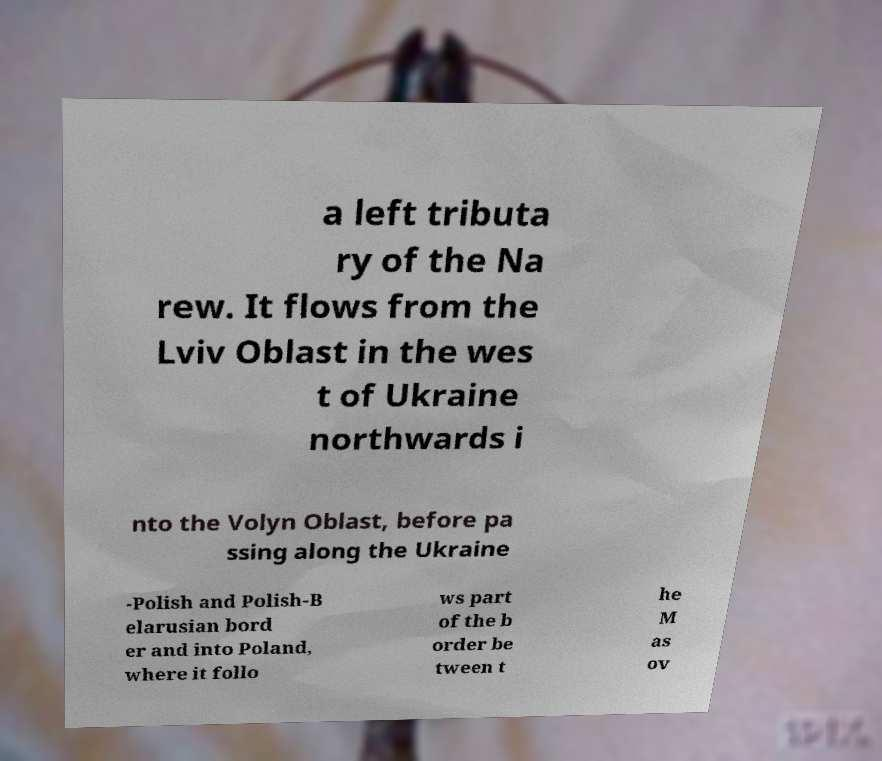Can you accurately transcribe the text from the provided image for me? a left tributa ry of the Na rew. It flows from the Lviv Oblast in the wes t of Ukraine northwards i nto the Volyn Oblast, before pa ssing along the Ukraine -Polish and Polish-B elarusian bord er and into Poland, where it follo ws part of the b order be tween t he M as ov 